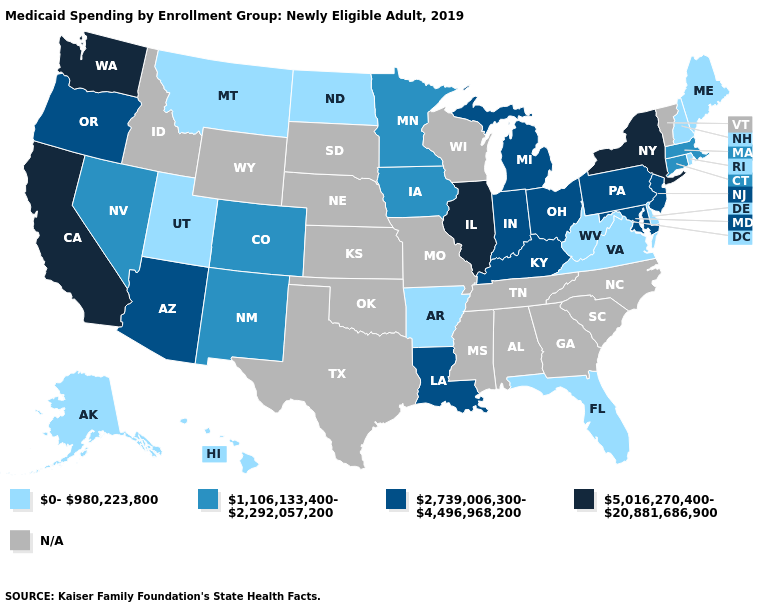What is the value of Wisconsin?
Keep it brief. N/A. What is the value of North Dakota?
Give a very brief answer. 0-980,223,800. Does New York have the highest value in the Northeast?
Be succinct. Yes. How many symbols are there in the legend?
Answer briefly. 5. Does the first symbol in the legend represent the smallest category?
Write a very short answer. Yes. Name the states that have a value in the range 2,739,006,300-4,496,968,200?
Quick response, please. Arizona, Indiana, Kentucky, Louisiana, Maryland, Michigan, New Jersey, Ohio, Oregon, Pennsylvania. How many symbols are there in the legend?
Write a very short answer. 5. Does California have the lowest value in the West?
Quick response, please. No. Name the states that have a value in the range 5,016,270,400-20,881,686,900?
Short answer required. California, Illinois, New York, Washington. What is the value of West Virginia?
Give a very brief answer. 0-980,223,800. Name the states that have a value in the range 5,016,270,400-20,881,686,900?
Answer briefly. California, Illinois, New York, Washington. Is the legend a continuous bar?
Quick response, please. No. 